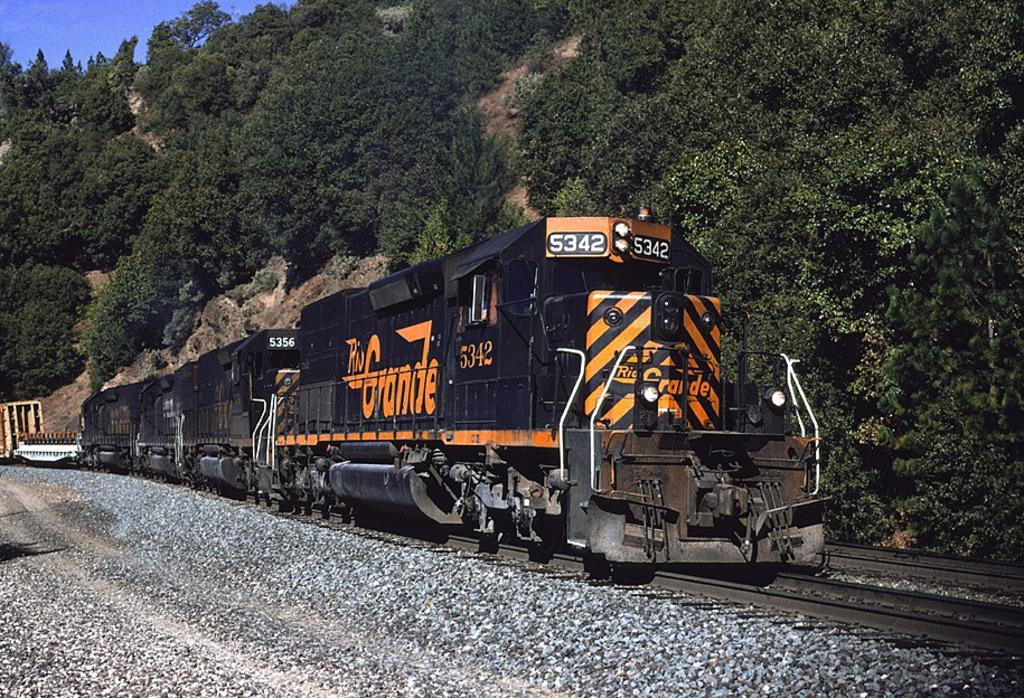What is the main subject of the image? The main subject of the image is a train. Where is the train located in the image? The train is on a railway track. What type of natural elements can be seen in the image? There are stones and trees visible in the image. What is visible in the background of the image? The sky is visible in the background of the image. What is the color of the sky in the image? The color of the sky is blue. Where is the nearest army base in the image? There is no army base present in the image. What type of medical facility is located near the train in the image? There is no hospital or medical facility present in the image. 